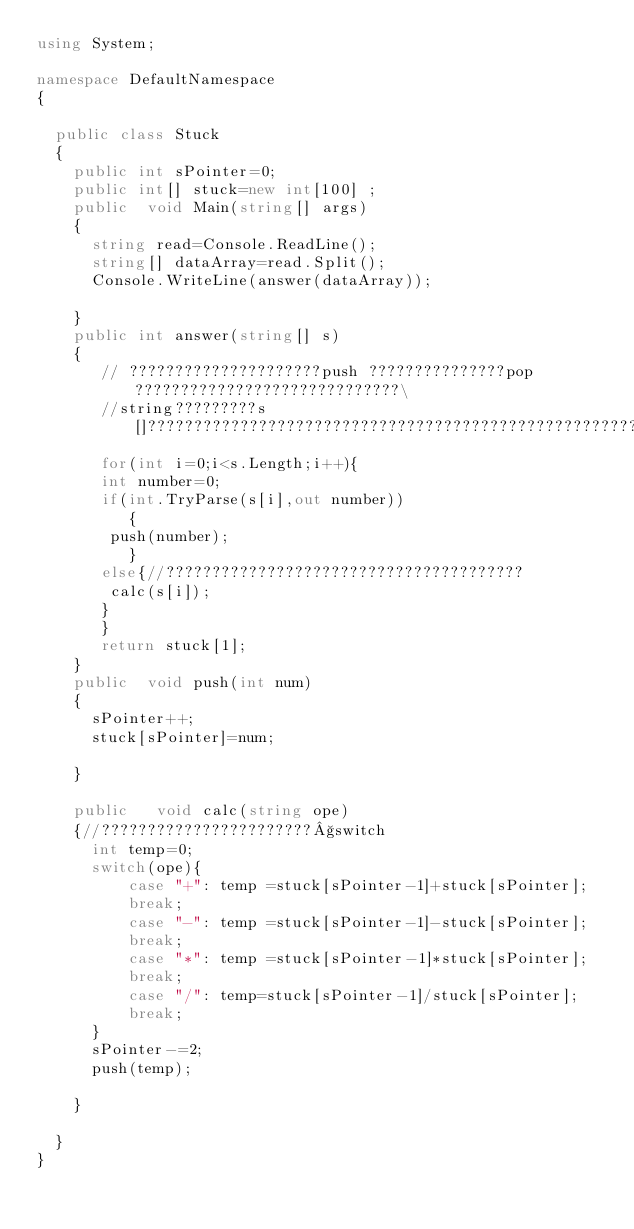<code> <loc_0><loc_0><loc_500><loc_500><_C#_>using System;

namespace DefaultNamespace
{
	
	public class Stuck
	{
		public int sPointer=0;
		public int[] stuck=new int[100] ;
		public  void Main(string[] args)
		{
			string read=Console.ReadLine();
			string[] dataArray=read.Split();
			Console.WriteLine(answer(dataArray));
			
		}
		public int answer(string[] s)
		{
		   // ?????????????????????push ???????????????pop ?????????????????????????????\
		   //string?????????s[]????????????????????????????????????????????????????????????????????????????????????????????????
		   for(int i=0;i<s.Length;i++){
		   int number=0;
		   if(int.TryParse(s[i],out number))
		      {
		   	push(number);
		      }
		   else{//???????????????????????????????????????
		   	calc(s[i]);
		   }
		   }
		   return stuck[1];
		}
		public  void push(int num)
		{
			sPointer++;
			stuck[sPointer]=num;
			
		}
		
		public   void calc(string ope)
		{//???????????????????????§switch
			int temp=0;
			switch(ope){
					case "+": temp =stuck[sPointer-1]+stuck[sPointer];
					break;
					case "-": temp =stuck[sPointer-1]-stuck[sPointer];
					break;
					case "*": temp =stuck[sPointer-1]*stuck[sPointer];
					break;
					case "/": temp=stuck[sPointer-1]/stuck[sPointer];
					break;
			}
			sPointer-=2;
			push(temp);
			
		}
		
	}
}</code> 